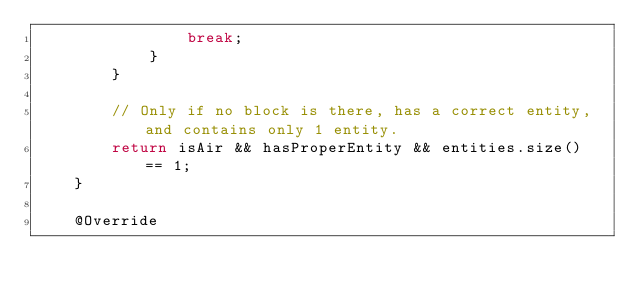<code> <loc_0><loc_0><loc_500><loc_500><_Java_>                break;
            }
        }

        // Only if no block is there, has a correct entity, and contains only 1 entity.
        return isAir && hasProperEntity && entities.size() == 1;
    }

    @Override</code> 